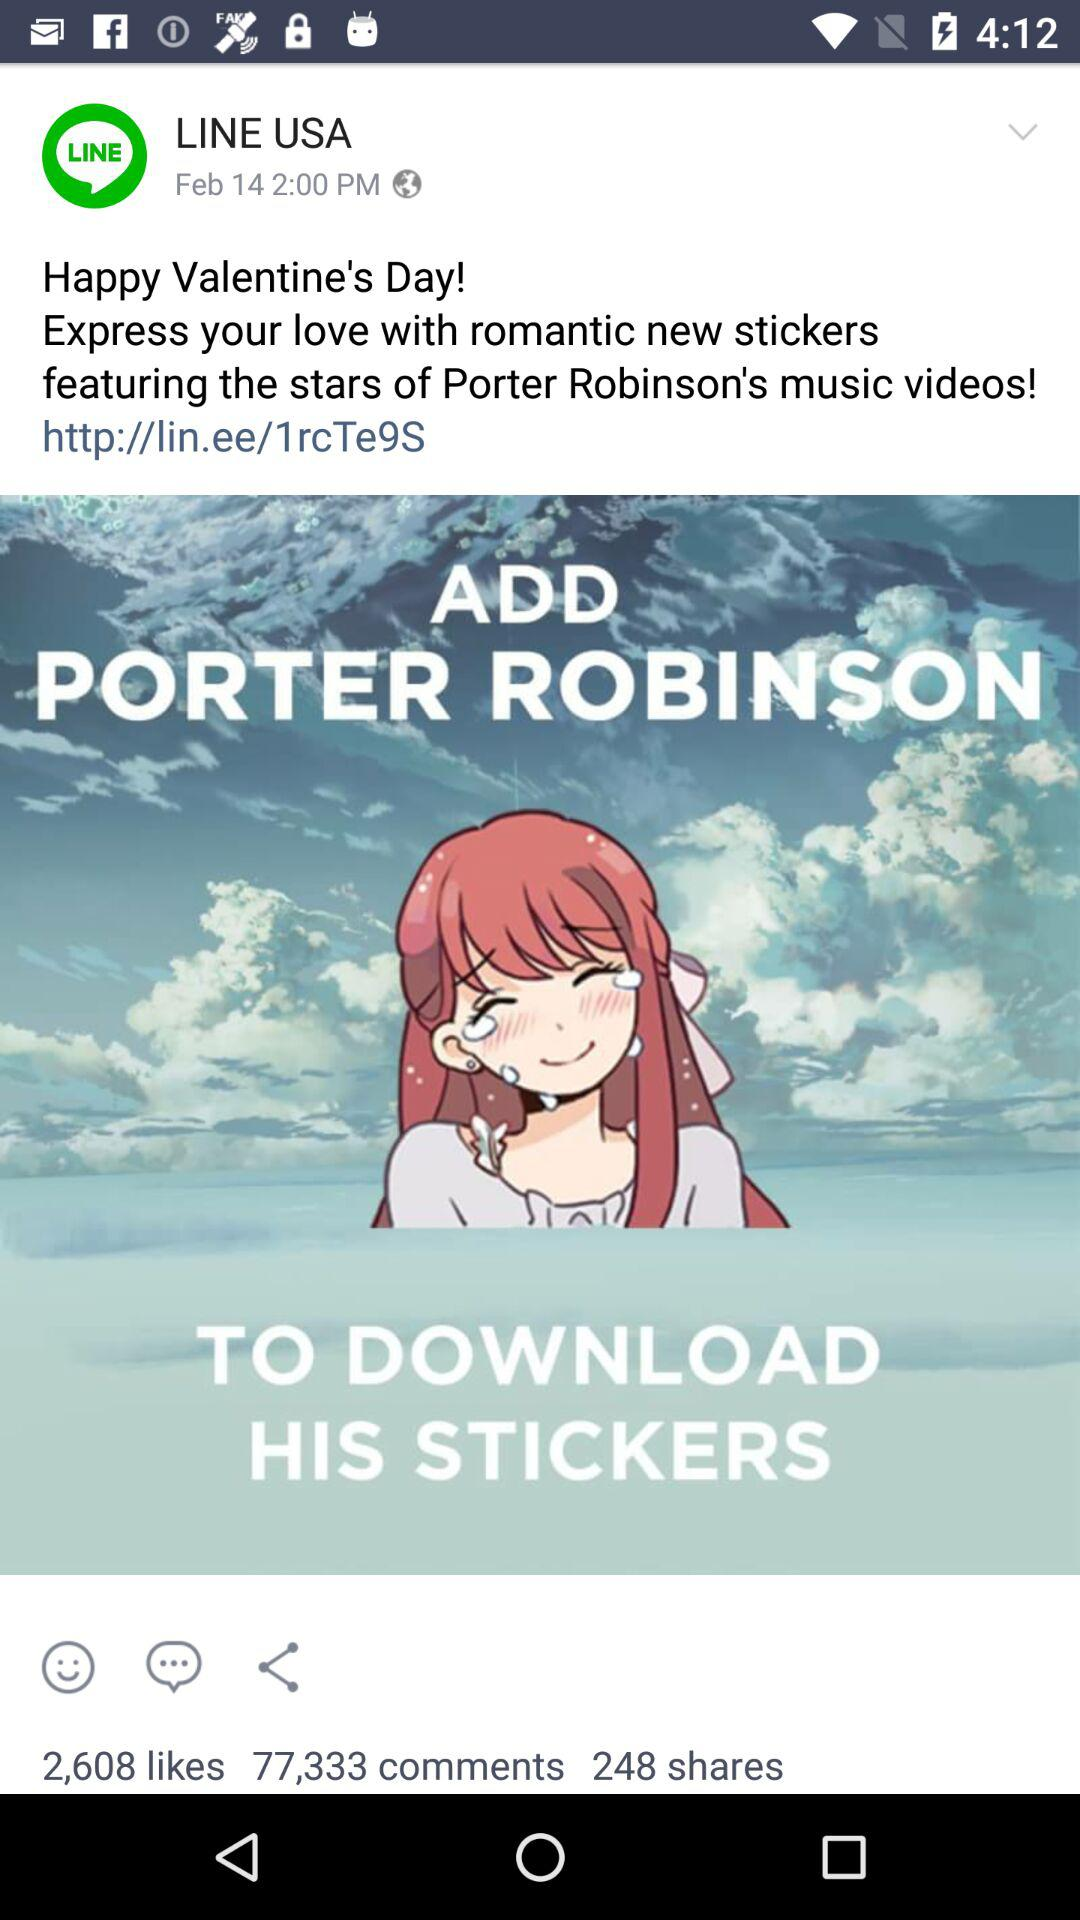When was the Valentine's Day sticker post uploaded? It was uploaded on February 14 at 2 pm. 